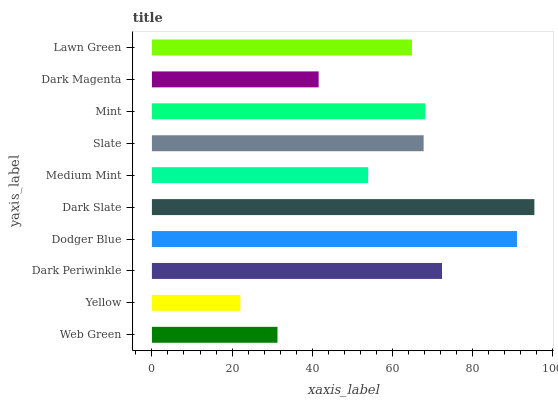Is Yellow the minimum?
Answer yes or no. Yes. Is Dark Slate the maximum?
Answer yes or no. Yes. Is Dark Periwinkle the minimum?
Answer yes or no. No. Is Dark Periwinkle the maximum?
Answer yes or no. No. Is Dark Periwinkle greater than Yellow?
Answer yes or no. Yes. Is Yellow less than Dark Periwinkle?
Answer yes or no. Yes. Is Yellow greater than Dark Periwinkle?
Answer yes or no. No. Is Dark Periwinkle less than Yellow?
Answer yes or no. No. Is Slate the high median?
Answer yes or no. Yes. Is Lawn Green the low median?
Answer yes or no. Yes. Is Medium Mint the high median?
Answer yes or no. No. Is Dark Slate the low median?
Answer yes or no. No. 